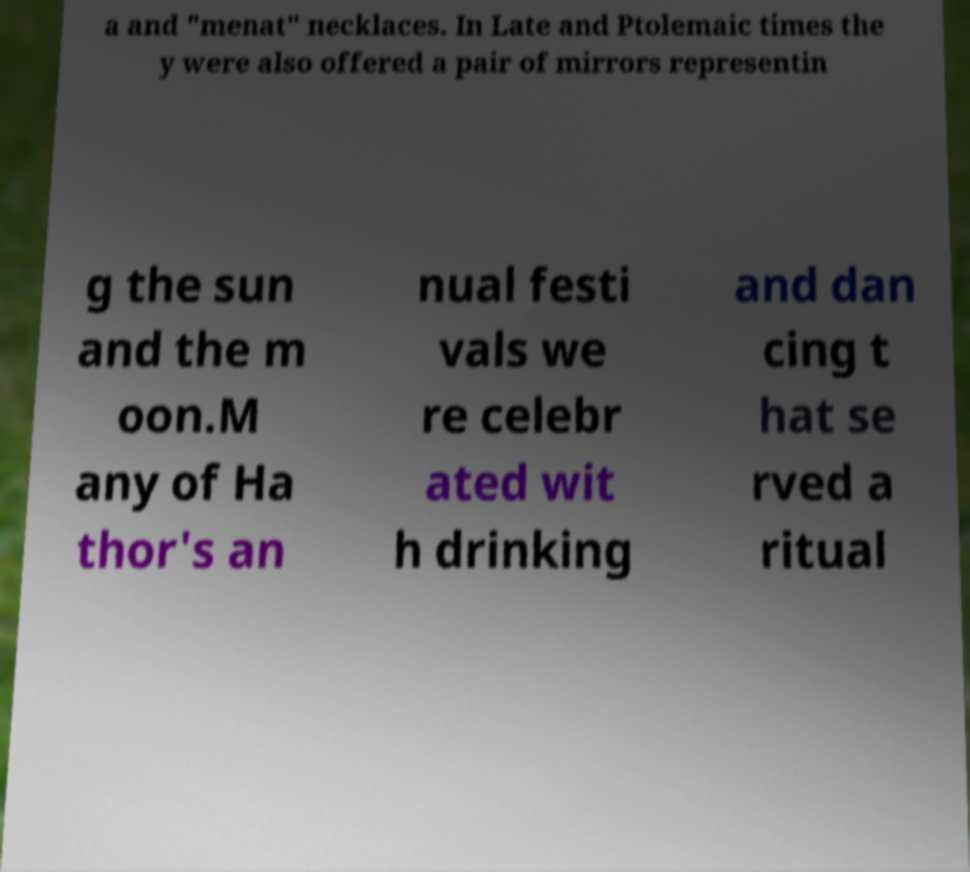Can you read and provide the text displayed in the image?This photo seems to have some interesting text. Can you extract and type it out for me? a and "menat" necklaces. In Late and Ptolemaic times the y were also offered a pair of mirrors representin g the sun and the m oon.M any of Ha thor's an nual festi vals we re celebr ated wit h drinking and dan cing t hat se rved a ritual 